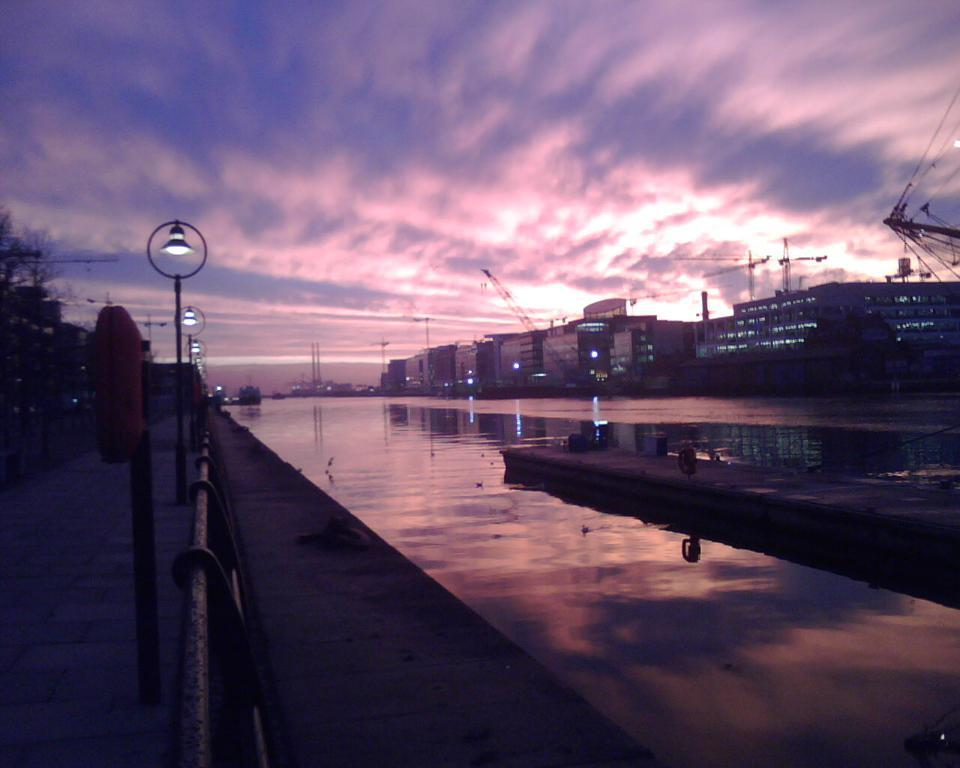What type of structures can be seen in the image? There are buildings in the image. What machinery is present in the image? There are cranes in the image. What natural element is visible in the image? There is water visible in the image. What type of lighting is present in the image? Pole lights are present in the image. What type of vegetation is in the image? There are trees in the image. What is the condition of the sky in the image? The sky is cloudy in the image. What type of flesh can be seen on the trees in the image? There is no flesh present on the trees in the image; they are made of wood and leaves. What type of beast is visible in the water in the image? There are no beasts visible in the water in the image; only water is present. 